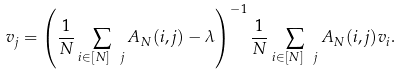Convert formula to latex. <formula><loc_0><loc_0><loc_500><loc_500>v _ { j } = \left ( \frac { 1 } { N } \sum _ { i \in [ N ] \ j } A _ { N } ( i , j ) - \lambda \right ) ^ { - 1 } \frac { 1 } { N } \sum _ { i \in [ N ] \ j } A _ { N } ( i , j ) v _ { i } .</formula> 